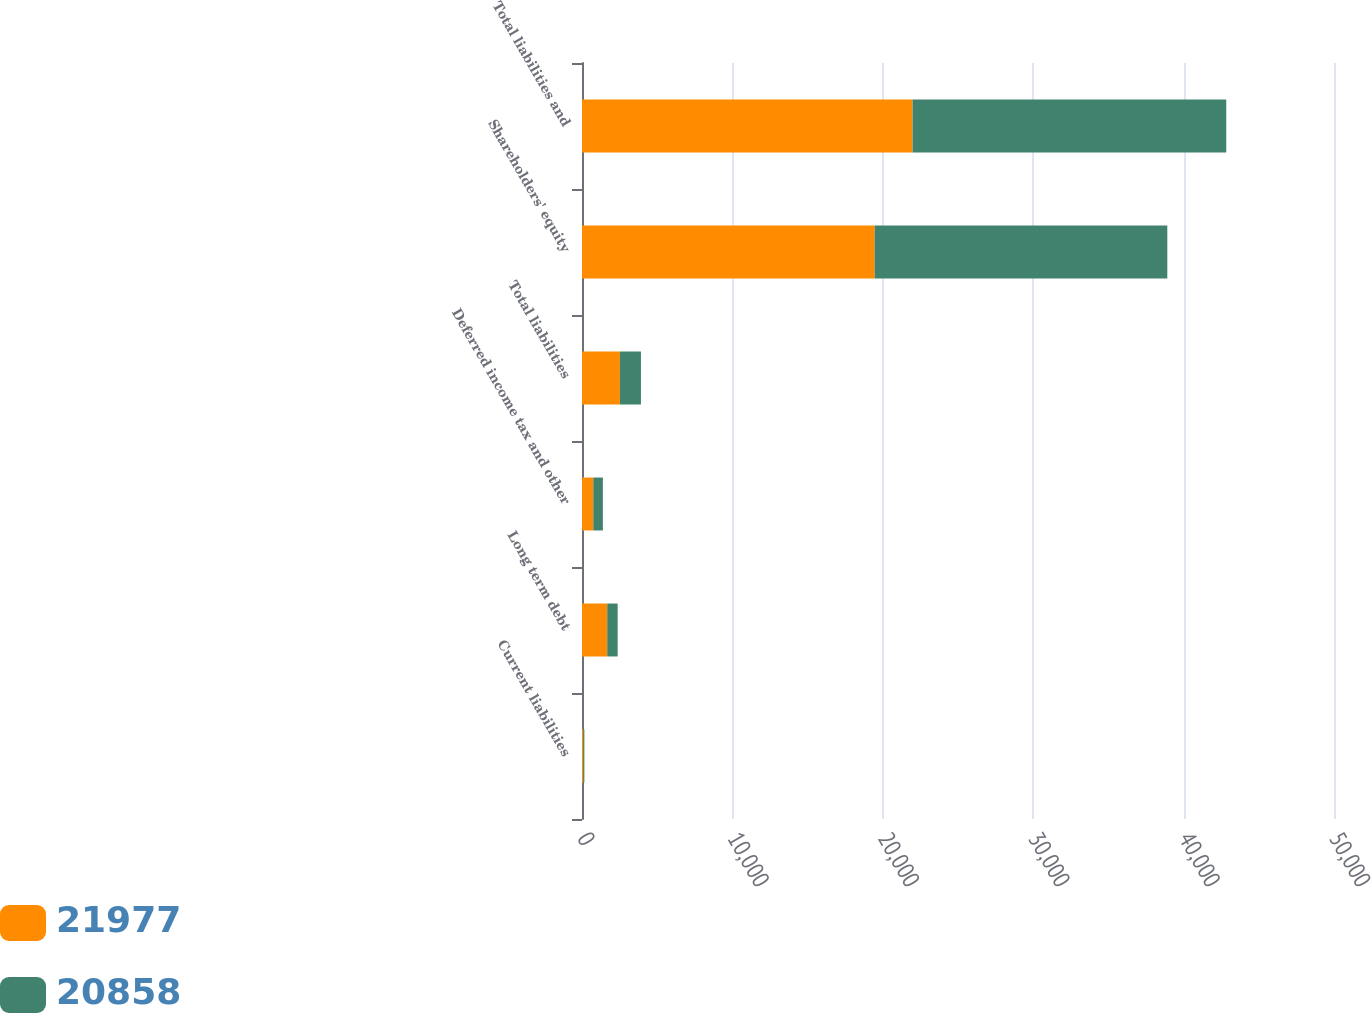<chart> <loc_0><loc_0><loc_500><loc_500><stacked_bar_chart><ecel><fcel>Current liabilities<fcel>Long term debt<fcel>Deferred income tax and other<fcel>Total liabilities<fcel>Shareholders' equity<fcel>Total liabilities and<nl><fcel>21977<fcel>91<fcel>1678<fcel>750<fcel>2519<fcel>19458<fcel>21977<nl><fcel>20858<fcel>67<fcel>693<fcel>639<fcel>1399<fcel>19459<fcel>20858<nl></chart> 